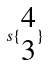<formula> <loc_0><loc_0><loc_500><loc_500>s \{ \begin{matrix} 4 \\ 3 \end{matrix} \}</formula> 